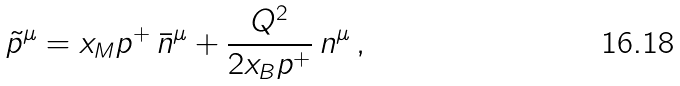Convert formula to latex. <formula><loc_0><loc_0><loc_500><loc_500>\tilde { p } ^ { \mu } = x _ { M } p ^ { + } \, \bar { n } ^ { \mu } + \frac { Q ^ { 2 } } { 2 x _ { B } p ^ { + } } \, n ^ { \mu } \, ,</formula> 